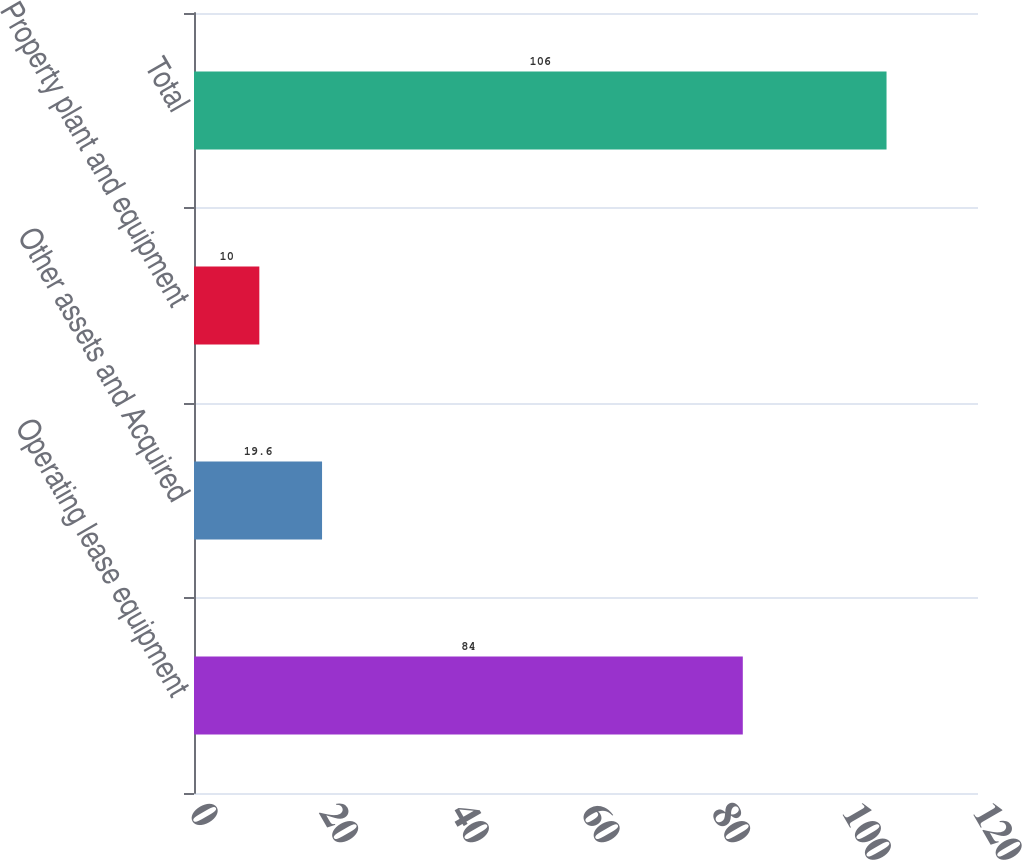<chart> <loc_0><loc_0><loc_500><loc_500><bar_chart><fcel>Operating lease equipment<fcel>Other assets and Acquired<fcel>Property plant and equipment<fcel>Total<nl><fcel>84<fcel>19.6<fcel>10<fcel>106<nl></chart> 